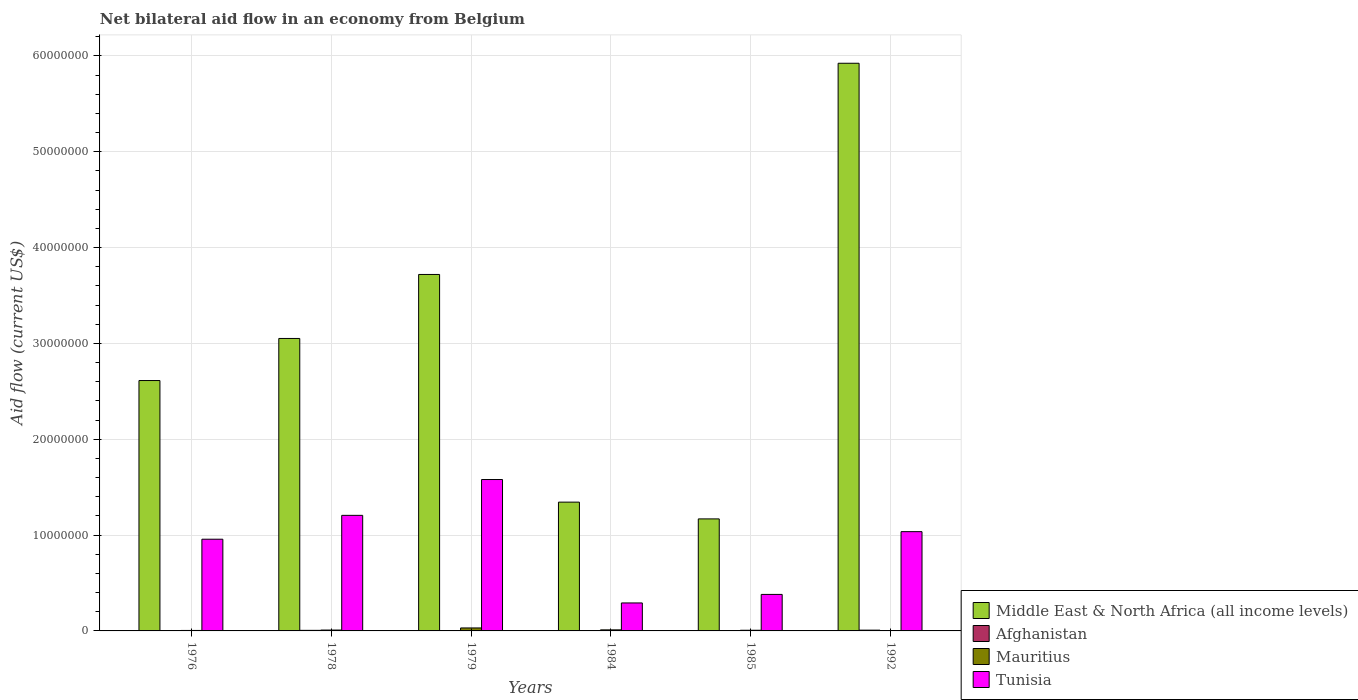How many different coloured bars are there?
Keep it short and to the point. 4. How many bars are there on the 1st tick from the left?
Your answer should be compact. 4. How many bars are there on the 2nd tick from the right?
Offer a very short reply. 4. What is the label of the 2nd group of bars from the left?
Offer a very short reply. 1978. In how many cases, is the number of bars for a given year not equal to the number of legend labels?
Offer a terse response. 0. What is the net bilateral aid flow in Middle East & North Africa (all income levels) in 1985?
Offer a very short reply. 1.17e+07. Across all years, what is the maximum net bilateral aid flow in Tunisia?
Your response must be concise. 1.58e+07. What is the total net bilateral aid flow in Middle East & North Africa (all income levels) in the graph?
Make the answer very short. 1.78e+08. What is the difference between the net bilateral aid flow in Middle East & North Africa (all income levels) in 1976 and the net bilateral aid flow in Tunisia in 1984?
Your answer should be very brief. 2.32e+07. What is the average net bilateral aid flow in Mauritius per year?
Your response must be concise. 1.10e+05. In the year 1976, what is the difference between the net bilateral aid flow in Middle East & North Africa (all income levels) and net bilateral aid flow in Afghanistan?
Ensure brevity in your answer.  2.61e+07. In how many years, is the net bilateral aid flow in Mauritius greater than 56000000 US$?
Make the answer very short. 0. Is the net bilateral aid flow in Afghanistan in 1979 less than that in 1985?
Your response must be concise. No. In how many years, is the net bilateral aid flow in Tunisia greater than the average net bilateral aid flow in Tunisia taken over all years?
Your response must be concise. 4. Is it the case that in every year, the sum of the net bilateral aid flow in Tunisia and net bilateral aid flow in Middle East & North Africa (all income levels) is greater than the sum of net bilateral aid flow in Mauritius and net bilateral aid flow in Afghanistan?
Provide a short and direct response. Yes. What does the 1st bar from the left in 1976 represents?
Your response must be concise. Middle East & North Africa (all income levels). What does the 4th bar from the right in 1984 represents?
Give a very brief answer. Middle East & North Africa (all income levels). Is it the case that in every year, the sum of the net bilateral aid flow in Afghanistan and net bilateral aid flow in Mauritius is greater than the net bilateral aid flow in Tunisia?
Your answer should be very brief. No. How many years are there in the graph?
Offer a very short reply. 6. Are the values on the major ticks of Y-axis written in scientific E-notation?
Offer a very short reply. No. Does the graph contain any zero values?
Make the answer very short. No. How are the legend labels stacked?
Provide a succinct answer. Vertical. What is the title of the graph?
Ensure brevity in your answer.  Net bilateral aid flow in an economy from Belgium. What is the label or title of the Y-axis?
Make the answer very short. Aid flow (current US$). What is the Aid flow (current US$) of Middle East & North Africa (all income levels) in 1976?
Provide a succinct answer. 2.61e+07. What is the Aid flow (current US$) of Mauritius in 1976?
Provide a short and direct response. 5.00e+04. What is the Aid flow (current US$) in Tunisia in 1976?
Offer a very short reply. 9.57e+06. What is the Aid flow (current US$) in Middle East & North Africa (all income levels) in 1978?
Make the answer very short. 3.05e+07. What is the Aid flow (current US$) in Tunisia in 1978?
Give a very brief answer. 1.21e+07. What is the Aid flow (current US$) in Middle East & North Africa (all income levels) in 1979?
Your answer should be compact. 3.72e+07. What is the Aid flow (current US$) in Tunisia in 1979?
Your response must be concise. 1.58e+07. What is the Aid flow (current US$) in Middle East & North Africa (all income levels) in 1984?
Your response must be concise. 1.34e+07. What is the Aid flow (current US$) in Mauritius in 1984?
Give a very brief answer. 1.10e+05. What is the Aid flow (current US$) of Tunisia in 1984?
Provide a succinct answer. 2.92e+06. What is the Aid flow (current US$) of Middle East & North Africa (all income levels) in 1985?
Your response must be concise. 1.17e+07. What is the Aid flow (current US$) in Afghanistan in 1985?
Keep it short and to the point. 3.00e+04. What is the Aid flow (current US$) of Mauritius in 1985?
Offer a terse response. 7.00e+04. What is the Aid flow (current US$) in Tunisia in 1985?
Provide a short and direct response. 3.81e+06. What is the Aid flow (current US$) in Middle East & North Africa (all income levels) in 1992?
Make the answer very short. 5.92e+07. What is the Aid flow (current US$) in Tunisia in 1992?
Your answer should be very brief. 1.04e+07. Across all years, what is the maximum Aid flow (current US$) of Middle East & North Africa (all income levels)?
Offer a very short reply. 5.92e+07. Across all years, what is the maximum Aid flow (current US$) in Tunisia?
Your answer should be compact. 1.58e+07. Across all years, what is the minimum Aid flow (current US$) in Middle East & North Africa (all income levels)?
Your answer should be very brief. 1.17e+07. Across all years, what is the minimum Aid flow (current US$) in Afghanistan?
Offer a very short reply. 3.00e+04. Across all years, what is the minimum Aid flow (current US$) of Mauritius?
Make the answer very short. 3.00e+04. Across all years, what is the minimum Aid flow (current US$) in Tunisia?
Your response must be concise. 2.92e+06. What is the total Aid flow (current US$) of Middle East & North Africa (all income levels) in the graph?
Keep it short and to the point. 1.78e+08. What is the total Aid flow (current US$) of Afghanistan in the graph?
Your answer should be compact. 2.80e+05. What is the total Aid flow (current US$) of Tunisia in the graph?
Provide a succinct answer. 5.45e+07. What is the difference between the Aid flow (current US$) in Middle East & North Africa (all income levels) in 1976 and that in 1978?
Your response must be concise. -4.39e+06. What is the difference between the Aid flow (current US$) in Afghanistan in 1976 and that in 1978?
Make the answer very short. -2.00e+04. What is the difference between the Aid flow (current US$) in Tunisia in 1976 and that in 1978?
Your response must be concise. -2.49e+06. What is the difference between the Aid flow (current US$) of Middle East & North Africa (all income levels) in 1976 and that in 1979?
Make the answer very short. -1.11e+07. What is the difference between the Aid flow (current US$) in Afghanistan in 1976 and that in 1979?
Offer a terse response. 0. What is the difference between the Aid flow (current US$) of Mauritius in 1976 and that in 1979?
Provide a succinct answer. -2.60e+05. What is the difference between the Aid flow (current US$) of Tunisia in 1976 and that in 1979?
Give a very brief answer. -6.23e+06. What is the difference between the Aid flow (current US$) of Middle East & North Africa (all income levels) in 1976 and that in 1984?
Make the answer very short. 1.27e+07. What is the difference between the Aid flow (current US$) of Mauritius in 1976 and that in 1984?
Your answer should be compact. -6.00e+04. What is the difference between the Aid flow (current US$) of Tunisia in 1976 and that in 1984?
Your answer should be compact. 6.65e+06. What is the difference between the Aid flow (current US$) of Middle East & North Africa (all income levels) in 1976 and that in 1985?
Give a very brief answer. 1.44e+07. What is the difference between the Aid flow (current US$) in Tunisia in 1976 and that in 1985?
Offer a very short reply. 5.76e+06. What is the difference between the Aid flow (current US$) of Middle East & North Africa (all income levels) in 1976 and that in 1992?
Keep it short and to the point. -3.31e+07. What is the difference between the Aid flow (current US$) of Mauritius in 1976 and that in 1992?
Your answer should be very brief. 2.00e+04. What is the difference between the Aid flow (current US$) in Tunisia in 1976 and that in 1992?
Make the answer very short. -7.90e+05. What is the difference between the Aid flow (current US$) in Middle East & North Africa (all income levels) in 1978 and that in 1979?
Give a very brief answer. -6.68e+06. What is the difference between the Aid flow (current US$) in Tunisia in 1978 and that in 1979?
Your response must be concise. -3.74e+06. What is the difference between the Aid flow (current US$) of Middle East & North Africa (all income levels) in 1978 and that in 1984?
Provide a short and direct response. 1.71e+07. What is the difference between the Aid flow (current US$) of Mauritius in 1978 and that in 1984?
Ensure brevity in your answer.  -2.00e+04. What is the difference between the Aid flow (current US$) in Tunisia in 1978 and that in 1984?
Your answer should be compact. 9.14e+06. What is the difference between the Aid flow (current US$) of Middle East & North Africa (all income levels) in 1978 and that in 1985?
Provide a short and direct response. 1.88e+07. What is the difference between the Aid flow (current US$) of Afghanistan in 1978 and that in 1985?
Provide a short and direct response. 3.00e+04. What is the difference between the Aid flow (current US$) in Mauritius in 1978 and that in 1985?
Provide a succinct answer. 2.00e+04. What is the difference between the Aid flow (current US$) in Tunisia in 1978 and that in 1985?
Provide a succinct answer. 8.25e+06. What is the difference between the Aid flow (current US$) of Middle East & North Africa (all income levels) in 1978 and that in 1992?
Provide a short and direct response. -2.87e+07. What is the difference between the Aid flow (current US$) of Afghanistan in 1978 and that in 1992?
Offer a terse response. -2.00e+04. What is the difference between the Aid flow (current US$) in Mauritius in 1978 and that in 1992?
Give a very brief answer. 6.00e+04. What is the difference between the Aid flow (current US$) of Tunisia in 1978 and that in 1992?
Your response must be concise. 1.70e+06. What is the difference between the Aid flow (current US$) of Middle East & North Africa (all income levels) in 1979 and that in 1984?
Provide a short and direct response. 2.38e+07. What is the difference between the Aid flow (current US$) in Afghanistan in 1979 and that in 1984?
Offer a terse response. 10000. What is the difference between the Aid flow (current US$) in Mauritius in 1979 and that in 1984?
Provide a short and direct response. 2.00e+05. What is the difference between the Aid flow (current US$) in Tunisia in 1979 and that in 1984?
Make the answer very short. 1.29e+07. What is the difference between the Aid flow (current US$) in Middle East & North Africa (all income levels) in 1979 and that in 1985?
Offer a terse response. 2.55e+07. What is the difference between the Aid flow (current US$) of Mauritius in 1979 and that in 1985?
Give a very brief answer. 2.40e+05. What is the difference between the Aid flow (current US$) of Tunisia in 1979 and that in 1985?
Provide a succinct answer. 1.20e+07. What is the difference between the Aid flow (current US$) of Middle East & North Africa (all income levels) in 1979 and that in 1992?
Your answer should be very brief. -2.20e+07. What is the difference between the Aid flow (current US$) of Mauritius in 1979 and that in 1992?
Give a very brief answer. 2.80e+05. What is the difference between the Aid flow (current US$) in Tunisia in 1979 and that in 1992?
Make the answer very short. 5.44e+06. What is the difference between the Aid flow (current US$) of Middle East & North Africa (all income levels) in 1984 and that in 1985?
Your response must be concise. 1.75e+06. What is the difference between the Aid flow (current US$) of Afghanistan in 1984 and that in 1985?
Offer a very short reply. 0. What is the difference between the Aid flow (current US$) in Tunisia in 1984 and that in 1985?
Your answer should be compact. -8.90e+05. What is the difference between the Aid flow (current US$) of Middle East & North Africa (all income levels) in 1984 and that in 1992?
Give a very brief answer. -4.58e+07. What is the difference between the Aid flow (current US$) in Mauritius in 1984 and that in 1992?
Offer a very short reply. 8.00e+04. What is the difference between the Aid flow (current US$) in Tunisia in 1984 and that in 1992?
Provide a short and direct response. -7.44e+06. What is the difference between the Aid flow (current US$) in Middle East & North Africa (all income levels) in 1985 and that in 1992?
Offer a very short reply. -4.76e+07. What is the difference between the Aid flow (current US$) of Afghanistan in 1985 and that in 1992?
Ensure brevity in your answer.  -5.00e+04. What is the difference between the Aid flow (current US$) of Mauritius in 1985 and that in 1992?
Offer a terse response. 4.00e+04. What is the difference between the Aid flow (current US$) in Tunisia in 1985 and that in 1992?
Ensure brevity in your answer.  -6.55e+06. What is the difference between the Aid flow (current US$) in Middle East & North Africa (all income levels) in 1976 and the Aid flow (current US$) in Afghanistan in 1978?
Provide a short and direct response. 2.61e+07. What is the difference between the Aid flow (current US$) in Middle East & North Africa (all income levels) in 1976 and the Aid flow (current US$) in Mauritius in 1978?
Offer a terse response. 2.60e+07. What is the difference between the Aid flow (current US$) in Middle East & North Africa (all income levels) in 1976 and the Aid flow (current US$) in Tunisia in 1978?
Your answer should be very brief. 1.41e+07. What is the difference between the Aid flow (current US$) in Afghanistan in 1976 and the Aid flow (current US$) in Mauritius in 1978?
Make the answer very short. -5.00e+04. What is the difference between the Aid flow (current US$) of Afghanistan in 1976 and the Aid flow (current US$) of Tunisia in 1978?
Your response must be concise. -1.20e+07. What is the difference between the Aid flow (current US$) in Mauritius in 1976 and the Aid flow (current US$) in Tunisia in 1978?
Provide a succinct answer. -1.20e+07. What is the difference between the Aid flow (current US$) in Middle East & North Africa (all income levels) in 1976 and the Aid flow (current US$) in Afghanistan in 1979?
Provide a succinct answer. 2.61e+07. What is the difference between the Aid flow (current US$) in Middle East & North Africa (all income levels) in 1976 and the Aid flow (current US$) in Mauritius in 1979?
Your answer should be compact. 2.58e+07. What is the difference between the Aid flow (current US$) in Middle East & North Africa (all income levels) in 1976 and the Aid flow (current US$) in Tunisia in 1979?
Your answer should be very brief. 1.03e+07. What is the difference between the Aid flow (current US$) in Afghanistan in 1976 and the Aid flow (current US$) in Mauritius in 1979?
Your response must be concise. -2.70e+05. What is the difference between the Aid flow (current US$) of Afghanistan in 1976 and the Aid flow (current US$) of Tunisia in 1979?
Offer a terse response. -1.58e+07. What is the difference between the Aid flow (current US$) of Mauritius in 1976 and the Aid flow (current US$) of Tunisia in 1979?
Keep it short and to the point. -1.58e+07. What is the difference between the Aid flow (current US$) in Middle East & North Africa (all income levels) in 1976 and the Aid flow (current US$) in Afghanistan in 1984?
Your answer should be very brief. 2.61e+07. What is the difference between the Aid flow (current US$) of Middle East & North Africa (all income levels) in 1976 and the Aid flow (current US$) of Mauritius in 1984?
Provide a succinct answer. 2.60e+07. What is the difference between the Aid flow (current US$) in Middle East & North Africa (all income levels) in 1976 and the Aid flow (current US$) in Tunisia in 1984?
Make the answer very short. 2.32e+07. What is the difference between the Aid flow (current US$) of Afghanistan in 1976 and the Aid flow (current US$) of Mauritius in 1984?
Ensure brevity in your answer.  -7.00e+04. What is the difference between the Aid flow (current US$) of Afghanistan in 1976 and the Aid flow (current US$) of Tunisia in 1984?
Provide a short and direct response. -2.88e+06. What is the difference between the Aid flow (current US$) in Mauritius in 1976 and the Aid flow (current US$) in Tunisia in 1984?
Make the answer very short. -2.87e+06. What is the difference between the Aid flow (current US$) in Middle East & North Africa (all income levels) in 1976 and the Aid flow (current US$) in Afghanistan in 1985?
Offer a very short reply. 2.61e+07. What is the difference between the Aid flow (current US$) of Middle East & North Africa (all income levels) in 1976 and the Aid flow (current US$) of Mauritius in 1985?
Offer a terse response. 2.61e+07. What is the difference between the Aid flow (current US$) of Middle East & North Africa (all income levels) in 1976 and the Aid flow (current US$) of Tunisia in 1985?
Offer a terse response. 2.23e+07. What is the difference between the Aid flow (current US$) in Afghanistan in 1976 and the Aid flow (current US$) in Tunisia in 1985?
Your answer should be compact. -3.77e+06. What is the difference between the Aid flow (current US$) in Mauritius in 1976 and the Aid flow (current US$) in Tunisia in 1985?
Provide a succinct answer. -3.76e+06. What is the difference between the Aid flow (current US$) in Middle East & North Africa (all income levels) in 1976 and the Aid flow (current US$) in Afghanistan in 1992?
Offer a very short reply. 2.60e+07. What is the difference between the Aid flow (current US$) of Middle East & North Africa (all income levels) in 1976 and the Aid flow (current US$) of Mauritius in 1992?
Your answer should be compact. 2.61e+07. What is the difference between the Aid flow (current US$) in Middle East & North Africa (all income levels) in 1976 and the Aid flow (current US$) in Tunisia in 1992?
Ensure brevity in your answer.  1.58e+07. What is the difference between the Aid flow (current US$) in Afghanistan in 1976 and the Aid flow (current US$) in Tunisia in 1992?
Provide a short and direct response. -1.03e+07. What is the difference between the Aid flow (current US$) in Mauritius in 1976 and the Aid flow (current US$) in Tunisia in 1992?
Ensure brevity in your answer.  -1.03e+07. What is the difference between the Aid flow (current US$) in Middle East & North Africa (all income levels) in 1978 and the Aid flow (current US$) in Afghanistan in 1979?
Keep it short and to the point. 3.05e+07. What is the difference between the Aid flow (current US$) of Middle East & North Africa (all income levels) in 1978 and the Aid flow (current US$) of Mauritius in 1979?
Keep it short and to the point. 3.02e+07. What is the difference between the Aid flow (current US$) of Middle East & North Africa (all income levels) in 1978 and the Aid flow (current US$) of Tunisia in 1979?
Your response must be concise. 1.47e+07. What is the difference between the Aid flow (current US$) of Afghanistan in 1978 and the Aid flow (current US$) of Mauritius in 1979?
Ensure brevity in your answer.  -2.50e+05. What is the difference between the Aid flow (current US$) of Afghanistan in 1978 and the Aid flow (current US$) of Tunisia in 1979?
Ensure brevity in your answer.  -1.57e+07. What is the difference between the Aid flow (current US$) of Mauritius in 1978 and the Aid flow (current US$) of Tunisia in 1979?
Keep it short and to the point. -1.57e+07. What is the difference between the Aid flow (current US$) in Middle East & North Africa (all income levels) in 1978 and the Aid flow (current US$) in Afghanistan in 1984?
Make the answer very short. 3.05e+07. What is the difference between the Aid flow (current US$) of Middle East & North Africa (all income levels) in 1978 and the Aid flow (current US$) of Mauritius in 1984?
Provide a short and direct response. 3.04e+07. What is the difference between the Aid flow (current US$) in Middle East & North Africa (all income levels) in 1978 and the Aid flow (current US$) in Tunisia in 1984?
Your answer should be very brief. 2.76e+07. What is the difference between the Aid flow (current US$) of Afghanistan in 1978 and the Aid flow (current US$) of Mauritius in 1984?
Your answer should be compact. -5.00e+04. What is the difference between the Aid flow (current US$) of Afghanistan in 1978 and the Aid flow (current US$) of Tunisia in 1984?
Keep it short and to the point. -2.86e+06. What is the difference between the Aid flow (current US$) in Mauritius in 1978 and the Aid flow (current US$) in Tunisia in 1984?
Your answer should be compact. -2.83e+06. What is the difference between the Aid flow (current US$) of Middle East & North Africa (all income levels) in 1978 and the Aid flow (current US$) of Afghanistan in 1985?
Offer a very short reply. 3.05e+07. What is the difference between the Aid flow (current US$) in Middle East & North Africa (all income levels) in 1978 and the Aid flow (current US$) in Mauritius in 1985?
Give a very brief answer. 3.04e+07. What is the difference between the Aid flow (current US$) of Middle East & North Africa (all income levels) in 1978 and the Aid flow (current US$) of Tunisia in 1985?
Your answer should be very brief. 2.67e+07. What is the difference between the Aid flow (current US$) in Afghanistan in 1978 and the Aid flow (current US$) in Tunisia in 1985?
Ensure brevity in your answer.  -3.75e+06. What is the difference between the Aid flow (current US$) in Mauritius in 1978 and the Aid flow (current US$) in Tunisia in 1985?
Your answer should be very brief. -3.72e+06. What is the difference between the Aid flow (current US$) of Middle East & North Africa (all income levels) in 1978 and the Aid flow (current US$) of Afghanistan in 1992?
Offer a terse response. 3.04e+07. What is the difference between the Aid flow (current US$) in Middle East & North Africa (all income levels) in 1978 and the Aid flow (current US$) in Mauritius in 1992?
Make the answer very short. 3.05e+07. What is the difference between the Aid flow (current US$) of Middle East & North Africa (all income levels) in 1978 and the Aid flow (current US$) of Tunisia in 1992?
Your answer should be very brief. 2.02e+07. What is the difference between the Aid flow (current US$) of Afghanistan in 1978 and the Aid flow (current US$) of Mauritius in 1992?
Provide a succinct answer. 3.00e+04. What is the difference between the Aid flow (current US$) of Afghanistan in 1978 and the Aid flow (current US$) of Tunisia in 1992?
Give a very brief answer. -1.03e+07. What is the difference between the Aid flow (current US$) of Mauritius in 1978 and the Aid flow (current US$) of Tunisia in 1992?
Offer a terse response. -1.03e+07. What is the difference between the Aid flow (current US$) in Middle East & North Africa (all income levels) in 1979 and the Aid flow (current US$) in Afghanistan in 1984?
Offer a very short reply. 3.72e+07. What is the difference between the Aid flow (current US$) of Middle East & North Africa (all income levels) in 1979 and the Aid flow (current US$) of Mauritius in 1984?
Your answer should be very brief. 3.71e+07. What is the difference between the Aid flow (current US$) of Middle East & North Africa (all income levels) in 1979 and the Aid flow (current US$) of Tunisia in 1984?
Ensure brevity in your answer.  3.43e+07. What is the difference between the Aid flow (current US$) of Afghanistan in 1979 and the Aid flow (current US$) of Tunisia in 1984?
Your answer should be compact. -2.88e+06. What is the difference between the Aid flow (current US$) of Mauritius in 1979 and the Aid flow (current US$) of Tunisia in 1984?
Ensure brevity in your answer.  -2.61e+06. What is the difference between the Aid flow (current US$) in Middle East & North Africa (all income levels) in 1979 and the Aid flow (current US$) in Afghanistan in 1985?
Your answer should be compact. 3.72e+07. What is the difference between the Aid flow (current US$) in Middle East & North Africa (all income levels) in 1979 and the Aid flow (current US$) in Mauritius in 1985?
Make the answer very short. 3.71e+07. What is the difference between the Aid flow (current US$) in Middle East & North Africa (all income levels) in 1979 and the Aid flow (current US$) in Tunisia in 1985?
Ensure brevity in your answer.  3.34e+07. What is the difference between the Aid flow (current US$) in Afghanistan in 1979 and the Aid flow (current US$) in Tunisia in 1985?
Provide a short and direct response. -3.77e+06. What is the difference between the Aid flow (current US$) in Mauritius in 1979 and the Aid flow (current US$) in Tunisia in 1985?
Offer a very short reply. -3.50e+06. What is the difference between the Aid flow (current US$) in Middle East & North Africa (all income levels) in 1979 and the Aid flow (current US$) in Afghanistan in 1992?
Ensure brevity in your answer.  3.71e+07. What is the difference between the Aid flow (current US$) in Middle East & North Africa (all income levels) in 1979 and the Aid flow (current US$) in Mauritius in 1992?
Provide a short and direct response. 3.72e+07. What is the difference between the Aid flow (current US$) in Middle East & North Africa (all income levels) in 1979 and the Aid flow (current US$) in Tunisia in 1992?
Provide a succinct answer. 2.68e+07. What is the difference between the Aid flow (current US$) in Afghanistan in 1979 and the Aid flow (current US$) in Tunisia in 1992?
Provide a succinct answer. -1.03e+07. What is the difference between the Aid flow (current US$) of Mauritius in 1979 and the Aid flow (current US$) of Tunisia in 1992?
Make the answer very short. -1.00e+07. What is the difference between the Aid flow (current US$) of Middle East & North Africa (all income levels) in 1984 and the Aid flow (current US$) of Afghanistan in 1985?
Provide a short and direct response. 1.34e+07. What is the difference between the Aid flow (current US$) of Middle East & North Africa (all income levels) in 1984 and the Aid flow (current US$) of Mauritius in 1985?
Provide a short and direct response. 1.34e+07. What is the difference between the Aid flow (current US$) in Middle East & North Africa (all income levels) in 1984 and the Aid flow (current US$) in Tunisia in 1985?
Provide a succinct answer. 9.63e+06. What is the difference between the Aid flow (current US$) in Afghanistan in 1984 and the Aid flow (current US$) in Mauritius in 1985?
Your response must be concise. -4.00e+04. What is the difference between the Aid flow (current US$) in Afghanistan in 1984 and the Aid flow (current US$) in Tunisia in 1985?
Ensure brevity in your answer.  -3.78e+06. What is the difference between the Aid flow (current US$) in Mauritius in 1984 and the Aid flow (current US$) in Tunisia in 1985?
Your answer should be compact. -3.70e+06. What is the difference between the Aid flow (current US$) in Middle East & North Africa (all income levels) in 1984 and the Aid flow (current US$) in Afghanistan in 1992?
Your answer should be very brief. 1.34e+07. What is the difference between the Aid flow (current US$) in Middle East & North Africa (all income levels) in 1984 and the Aid flow (current US$) in Mauritius in 1992?
Provide a short and direct response. 1.34e+07. What is the difference between the Aid flow (current US$) in Middle East & North Africa (all income levels) in 1984 and the Aid flow (current US$) in Tunisia in 1992?
Your answer should be compact. 3.08e+06. What is the difference between the Aid flow (current US$) of Afghanistan in 1984 and the Aid flow (current US$) of Mauritius in 1992?
Offer a terse response. 0. What is the difference between the Aid flow (current US$) of Afghanistan in 1984 and the Aid flow (current US$) of Tunisia in 1992?
Provide a succinct answer. -1.03e+07. What is the difference between the Aid flow (current US$) of Mauritius in 1984 and the Aid flow (current US$) of Tunisia in 1992?
Ensure brevity in your answer.  -1.02e+07. What is the difference between the Aid flow (current US$) in Middle East & North Africa (all income levels) in 1985 and the Aid flow (current US$) in Afghanistan in 1992?
Your response must be concise. 1.16e+07. What is the difference between the Aid flow (current US$) of Middle East & North Africa (all income levels) in 1985 and the Aid flow (current US$) of Mauritius in 1992?
Give a very brief answer. 1.17e+07. What is the difference between the Aid flow (current US$) in Middle East & North Africa (all income levels) in 1985 and the Aid flow (current US$) in Tunisia in 1992?
Give a very brief answer. 1.33e+06. What is the difference between the Aid flow (current US$) of Afghanistan in 1985 and the Aid flow (current US$) of Tunisia in 1992?
Offer a very short reply. -1.03e+07. What is the difference between the Aid flow (current US$) in Mauritius in 1985 and the Aid flow (current US$) in Tunisia in 1992?
Offer a terse response. -1.03e+07. What is the average Aid flow (current US$) of Middle East & North Africa (all income levels) per year?
Your answer should be compact. 2.97e+07. What is the average Aid flow (current US$) of Afghanistan per year?
Provide a short and direct response. 4.67e+04. What is the average Aid flow (current US$) in Mauritius per year?
Make the answer very short. 1.10e+05. What is the average Aid flow (current US$) of Tunisia per year?
Your answer should be very brief. 9.09e+06. In the year 1976, what is the difference between the Aid flow (current US$) in Middle East & North Africa (all income levels) and Aid flow (current US$) in Afghanistan?
Provide a succinct answer. 2.61e+07. In the year 1976, what is the difference between the Aid flow (current US$) of Middle East & North Africa (all income levels) and Aid flow (current US$) of Mauritius?
Make the answer very short. 2.61e+07. In the year 1976, what is the difference between the Aid flow (current US$) of Middle East & North Africa (all income levels) and Aid flow (current US$) of Tunisia?
Provide a short and direct response. 1.66e+07. In the year 1976, what is the difference between the Aid flow (current US$) in Afghanistan and Aid flow (current US$) in Mauritius?
Your answer should be very brief. -10000. In the year 1976, what is the difference between the Aid flow (current US$) in Afghanistan and Aid flow (current US$) in Tunisia?
Provide a short and direct response. -9.53e+06. In the year 1976, what is the difference between the Aid flow (current US$) of Mauritius and Aid flow (current US$) of Tunisia?
Offer a very short reply. -9.52e+06. In the year 1978, what is the difference between the Aid flow (current US$) in Middle East & North Africa (all income levels) and Aid flow (current US$) in Afghanistan?
Provide a short and direct response. 3.05e+07. In the year 1978, what is the difference between the Aid flow (current US$) of Middle East & North Africa (all income levels) and Aid flow (current US$) of Mauritius?
Offer a very short reply. 3.04e+07. In the year 1978, what is the difference between the Aid flow (current US$) in Middle East & North Africa (all income levels) and Aid flow (current US$) in Tunisia?
Your answer should be very brief. 1.85e+07. In the year 1978, what is the difference between the Aid flow (current US$) in Afghanistan and Aid flow (current US$) in Mauritius?
Your response must be concise. -3.00e+04. In the year 1978, what is the difference between the Aid flow (current US$) in Afghanistan and Aid flow (current US$) in Tunisia?
Provide a succinct answer. -1.20e+07. In the year 1978, what is the difference between the Aid flow (current US$) in Mauritius and Aid flow (current US$) in Tunisia?
Offer a very short reply. -1.20e+07. In the year 1979, what is the difference between the Aid flow (current US$) of Middle East & North Africa (all income levels) and Aid flow (current US$) of Afghanistan?
Your response must be concise. 3.72e+07. In the year 1979, what is the difference between the Aid flow (current US$) in Middle East & North Africa (all income levels) and Aid flow (current US$) in Mauritius?
Offer a terse response. 3.69e+07. In the year 1979, what is the difference between the Aid flow (current US$) of Middle East & North Africa (all income levels) and Aid flow (current US$) of Tunisia?
Your answer should be compact. 2.14e+07. In the year 1979, what is the difference between the Aid flow (current US$) of Afghanistan and Aid flow (current US$) of Tunisia?
Ensure brevity in your answer.  -1.58e+07. In the year 1979, what is the difference between the Aid flow (current US$) of Mauritius and Aid flow (current US$) of Tunisia?
Your answer should be very brief. -1.55e+07. In the year 1984, what is the difference between the Aid flow (current US$) of Middle East & North Africa (all income levels) and Aid flow (current US$) of Afghanistan?
Make the answer very short. 1.34e+07. In the year 1984, what is the difference between the Aid flow (current US$) in Middle East & North Africa (all income levels) and Aid flow (current US$) in Mauritius?
Give a very brief answer. 1.33e+07. In the year 1984, what is the difference between the Aid flow (current US$) of Middle East & North Africa (all income levels) and Aid flow (current US$) of Tunisia?
Ensure brevity in your answer.  1.05e+07. In the year 1984, what is the difference between the Aid flow (current US$) of Afghanistan and Aid flow (current US$) of Tunisia?
Offer a very short reply. -2.89e+06. In the year 1984, what is the difference between the Aid flow (current US$) in Mauritius and Aid flow (current US$) in Tunisia?
Your response must be concise. -2.81e+06. In the year 1985, what is the difference between the Aid flow (current US$) of Middle East & North Africa (all income levels) and Aid flow (current US$) of Afghanistan?
Keep it short and to the point. 1.17e+07. In the year 1985, what is the difference between the Aid flow (current US$) in Middle East & North Africa (all income levels) and Aid flow (current US$) in Mauritius?
Give a very brief answer. 1.16e+07. In the year 1985, what is the difference between the Aid flow (current US$) of Middle East & North Africa (all income levels) and Aid flow (current US$) of Tunisia?
Ensure brevity in your answer.  7.88e+06. In the year 1985, what is the difference between the Aid flow (current US$) in Afghanistan and Aid flow (current US$) in Tunisia?
Offer a terse response. -3.78e+06. In the year 1985, what is the difference between the Aid flow (current US$) of Mauritius and Aid flow (current US$) of Tunisia?
Your response must be concise. -3.74e+06. In the year 1992, what is the difference between the Aid flow (current US$) in Middle East & North Africa (all income levels) and Aid flow (current US$) in Afghanistan?
Make the answer very short. 5.92e+07. In the year 1992, what is the difference between the Aid flow (current US$) of Middle East & North Africa (all income levels) and Aid flow (current US$) of Mauritius?
Your answer should be compact. 5.92e+07. In the year 1992, what is the difference between the Aid flow (current US$) in Middle East & North Africa (all income levels) and Aid flow (current US$) in Tunisia?
Keep it short and to the point. 4.89e+07. In the year 1992, what is the difference between the Aid flow (current US$) in Afghanistan and Aid flow (current US$) in Mauritius?
Offer a terse response. 5.00e+04. In the year 1992, what is the difference between the Aid flow (current US$) in Afghanistan and Aid flow (current US$) in Tunisia?
Ensure brevity in your answer.  -1.03e+07. In the year 1992, what is the difference between the Aid flow (current US$) of Mauritius and Aid flow (current US$) of Tunisia?
Give a very brief answer. -1.03e+07. What is the ratio of the Aid flow (current US$) in Middle East & North Africa (all income levels) in 1976 to that in 1978?
Your answer should be compact. 0.86. What is the ratio of the Aid flow (current US$) in Mauritius in 1976 to that in 1978?
Make the answer very short. 0.56. What is the ratio of the Aid flow (current US$) of Tunisia in 1976 to that in 1978?
Ensure brevity in your answer.  0.79. What is the ratio of the Aid flow (current US$) in Middle East & North Africa (all income levels) in 1976 to that in 1979?
Provide a short and direct response. 0.7. What is the ratio of the Aid flow (current US$) in Mauritius in 1976 to that in 1979?
Make the answer very short. 0.16. What is the ratio of the Aid flow (current US$) in Tunisia in 1976 to that in 1979?
Provide a succinct answer. 0.61. What is the ratio of the Aid flow (current US$) of Middle East & North Africa (all income levels) in 1976 to that in 1984?
Make the answer very short. 1.94. What is the ratio of the Aid flow (current US$) in Afghanistan in 1976 to that in 1984?
Your response must be concise. 1.33. What is the ratio of the Aid flow (current US$) in Mauritius in 1976 to that in 1984?
Your answer should be very brief. 0.45. What is the ratio of the Aid flow (current US$) in Tunisia in 1976 to that in 1984?
Make the answer very short. 3.28. What is the ratio of the Aid flow (current US$) in Middle East & North Africa (all income levels) in 1976 to that in 1985?
Make the answer very short. 2.24. What is the ratio of the Aid flow (current US$) of Tunisia in 1976 to that in 1985?
Provide a short and direct response. 2.51. What is the ratio of the Aid flow (current US$) of Middle East & North Africa (all income levels) in 1976 to that in 1992?
Give a very brief answer. 0.44. What is the ratio of the Aid flow (current US$) in Mauritius in 1976 to that in 1992?
Provide a succinct answer. 1.67. What is the ratio of the Aid flow (current US$) in Tunisia in 1976 to that in 1992?
Keep it short and to the point. 0.92. What is the ratio of the Aid flow (current US$) in Middle East & North Africa (all income levels) in 1978 to that in 1979?
Your answer should be very brief. 0.82. What is the ratio of the Aid flow (current US$) of Mauritius in 1978 to that in 1979?
Provide a short and direct response. 0.29. What is the ratio of the Aid flow (current US$) in Tunisia in 1978 to that in 1979?
Your answer should be compact. 0.76. What is the ratio of the Aid flow (current US$) of Middle East & North Africa (all income levels) in 1978 to that in 1984?
Provide a short and direct response. 2.27. What is the ratio of the Aid flow (current US$) in Mauritius in 1978 to that in 1984?
Keep it short and to the point. 0.82. What is the ratio of the Aid flow (current US$) of Tunisia in 1978 to that in 1984?
Your response must be concise. 4.13. What is the ratio of the Aid flow (current US$) in Middle East & North Africa (all income levels) in 1978 to that in 1985?
Make the answer very short. 2.61. What is the ratio of the Aid flow (current US$) in Afghanistan in 1978 to that in 1985?
Give a very brief answer. 2. What is the ratio of the Aid flow (current US$) of Mauritius in 1978 to that in 1985?
Ensure brevity in your answer.  1.29. What is the ratio of the Aid flow (current US$) in Tunisia in 1978 to that in 1985?
Offer a very short reply. 3.17. What is the ratio of the Aid flow (current US$) in Middle East & North Africa (all income levels) in 1978 to that in 1992?
Make the answer very short. 0.52. What is the ratio of the Aid flow (current US$) of Afghanistan in 1978 to that in 1992?
Keep it short and to the point. 0.75. What is the ratio of the Aid flow (current US$) in Tunisia in 1978 to that in 1992?
Offer a very short reply. 1.16. What is the ratio of the Aid flow (current US$) of Middle East & North Africa (all income levels) in 1979 to that in 1984?
Your response must be concise. 2.77. What is the ratio of the Aid flow (current US$) of Mauritius in 1979 to that in 1984?
Offer a terse response. 2.82. What is the ratio of the Aid flow (current US$) of Tunisia in 1979 to that in 1984?
Your answer should be very brief. 5.41. What is the ratio of the Aid flow (current US$) of Middle East & North Africa (all income levels) in 1979 to that in 1985?
Your answer should be compact. 3.18. What is the ratio of the Aid flow (current US$) in Mauritius in 1979 to that in 1985?
Keep it short and to the point. 4.43. What is the ratio of the Aid flow (current US$) of Tunisia in 1979 to that in 1985?
Offer a very short reply. 4.15. What is the ratio of the Aid flow (current US$) in Middle East & North Africa (all income levels) in 1979 to that in 1992?
Your answer should be compact. 0.63. What is the ratio of the Aid flow (current US$) of Mauritius in 1979 to that in 1992?
Your response must be concise. 10.33. What is the ratio of the Aid flow (current US$) of Tunisia in 1979 to that in 1992?
Provide a short and direct response. 1.53. What is the ratio of the Aid flow (current US$) of Middle East & North Africa (all income levels) in 1984 to that in 1985?
Offer a terse response. 1.15. What is the ratio of the Aid flow (current US$) in Afghanistan in 1984 to that in 1985?
Make the answer very short. 1. What is the ratio of the Aid flow (current US$) of Mauritius in 1984 to that in 1985?
Keep it short and to the point. 1.57. What is the ratio of the Aid flow (current US$) of Tunisia in 1984 to that in 1985?
Your response must be concise. 0.77. What is the ratio of the Aid flow (current US$) in Middle East & North Africa (all income levels) in 1984 to that in 1992?
Give a very brief answer. 0.23. What is the ratio of the Aid flow (current US$) of Mauritius in 1984 to that in 1992?
Offer a terse response. 3.67. What is the ratio of the Aid flow (current US$) of Tunisia in 1984 to that in 1992?
Your answer should be compact. 0.28. What is the ratio of the Aid flow (current US$) in Middle East & North Africa (all income levels) in 1985 to that in 1992?
Offer a very short reply. 0.2. What is the ratio of the Aid flow (current US$) of Mauritius in 1985 to that in 1992?
Your response must be concise. 2.33. What is the ratio of the Aid flow (current US$) of Tunisia in 1985 to that in 1992?
Give a very brief answer. 0.37. What is the difference between the highest and the second highest Aid flow (current US$) in Middle East & North Africa (all income levels)?
Provide a succinct answer. 2.20e+07. What is the difference between the highest and the second highest Aid flow (current US$) in Afghanistan?
Provide a succinct answer. 2.00e+04. What is the difference between the highest and the second highest Aid flow (current US$) in Tunisia?
Your answer should be very brief. 3.74e+06. What is the difference between the highest and the lowest Aid flow (current US$) of Middle East & North Africa (all income levels)?
Offer a terse response. 4.76e+07. What is the difference between the highest and the lowest Aid flow (current US$) of Mauritius?
Offer a very short reply. 2.80e+05. What is the difference between the highest and the lowest Aid flow (current US$) of Tunisia?
Provide a succinct answer. 1.29e+07. 